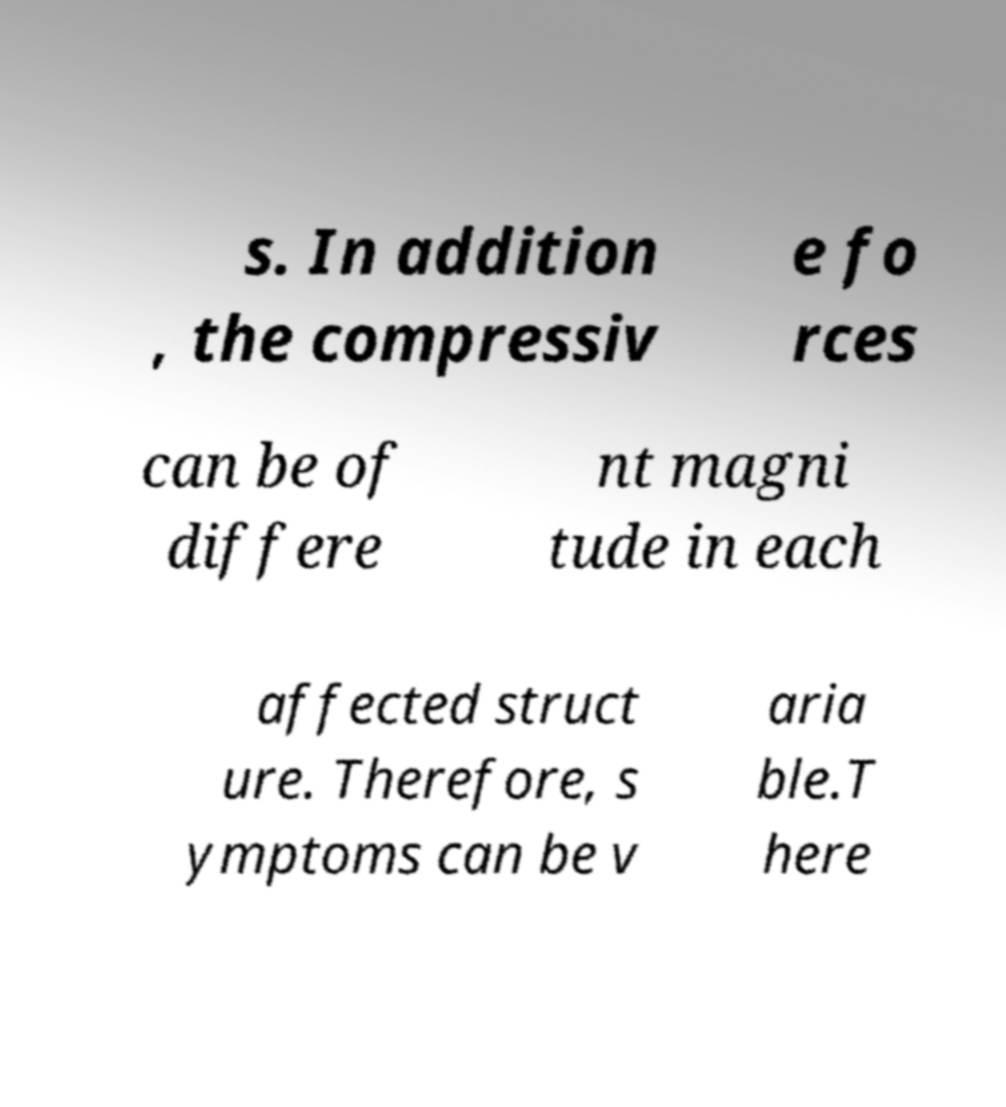Can you accurately transcribe the text from the provided image for me? s. In addition , the compressiv e fo rces can be of differe nt magni tude in each affected struct ure. Therefore, s ymptoms can be v aria ble.T here 